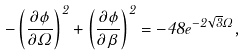Convert formula to latex. <formula><loc_0><loc_0><loc_500><loc_500>- \left ( \frac { \partial \phi } { \partial \Omega } \right ) ^ { 2 } + \left ( \frac { \partial \phi } { \partial \beta } \right ) ^ { 2 } = - 4 8 e ^ { - 2 \sqrt { 3 } \Omega } ,</formula> 